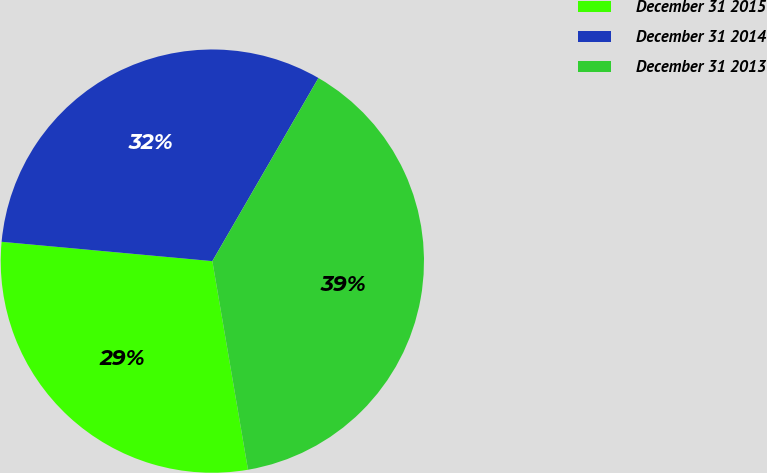Convert chart to OTSL. <chart><loc_0><loc_0><loc_500><loc_500><pie_chart><fcel>December 31 2015<fcel>December 31 2014<fcel>December 31 2013<nl><fcel>29.15%<fcel>31.9%<fcel>38.95%<nl></chart> 